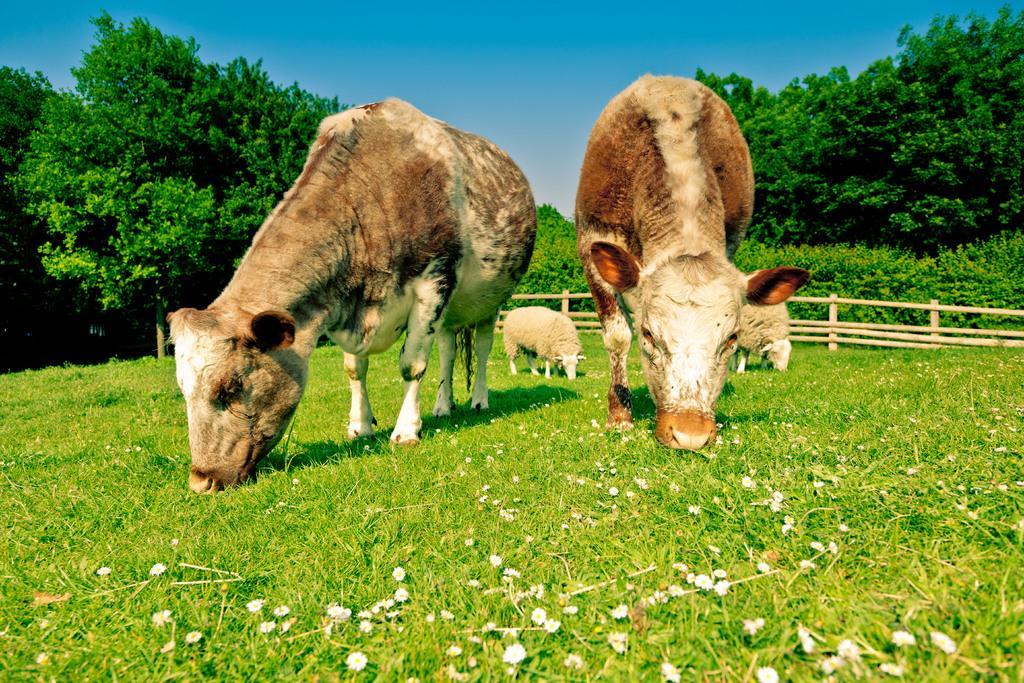Describe this image in one or two sentences. This picture is clicked outside. In the center two cows and two sheep standing on the ground and eating the grass. In the background there is a sky, trees, plants and a wooden fence. 